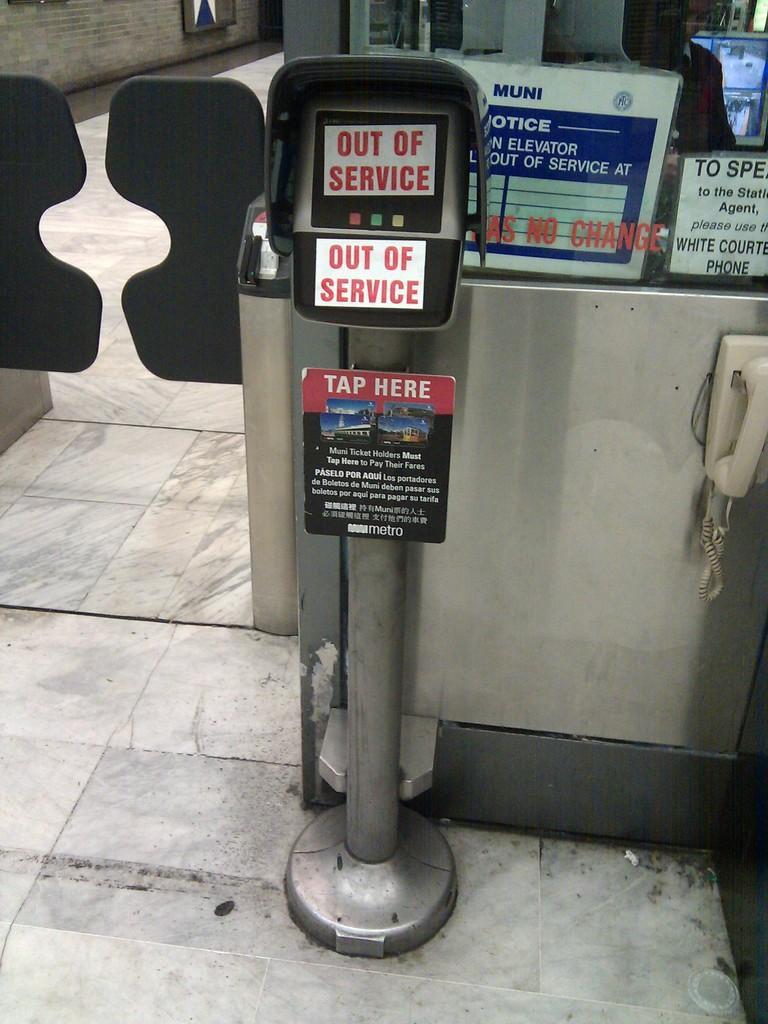In one or two sentences, can you explain what this image depicts? In this image I can see a machine. On the right side, I can see some board with some text written on it. 